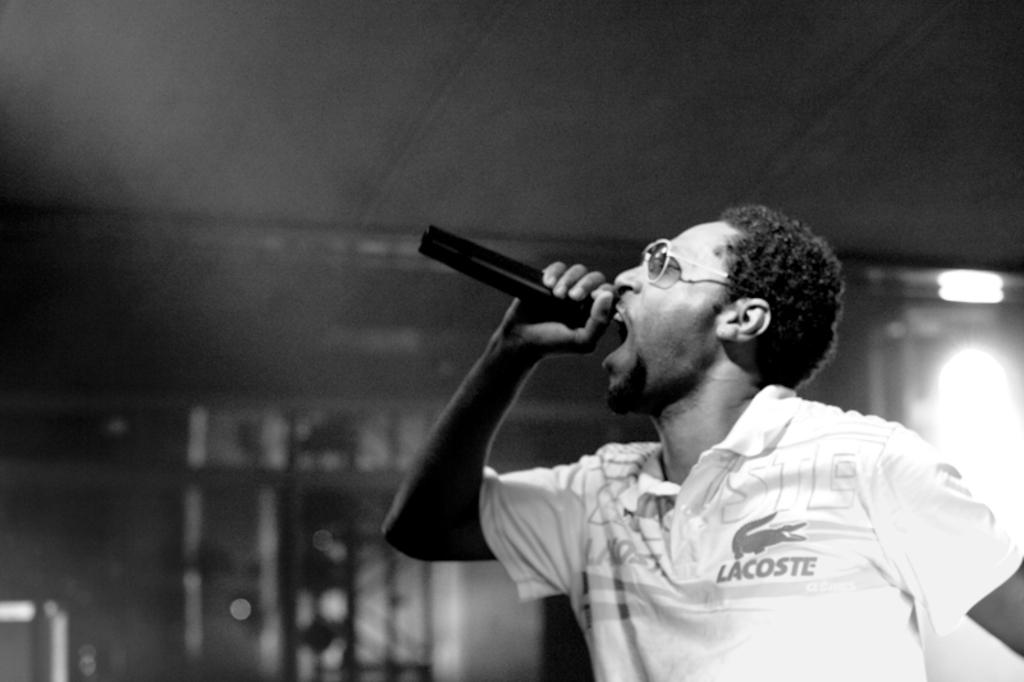What is the color scheme of the image? The image is black and white. Who is present in the image? There is a man in the image. What is the man holding in the image? The man is holding a microphone. What is the man doing in the image? The man is singing. Can you see any zebras in the image? No, there are no zebras present in the image. Does the man have any fangs visible in the image? No, the man does not have any fangs visible in the image. 